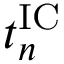<formula> <loc_0><loc_0><loc_500><loc_500>t _ { n } ^ { I C }</formula> 